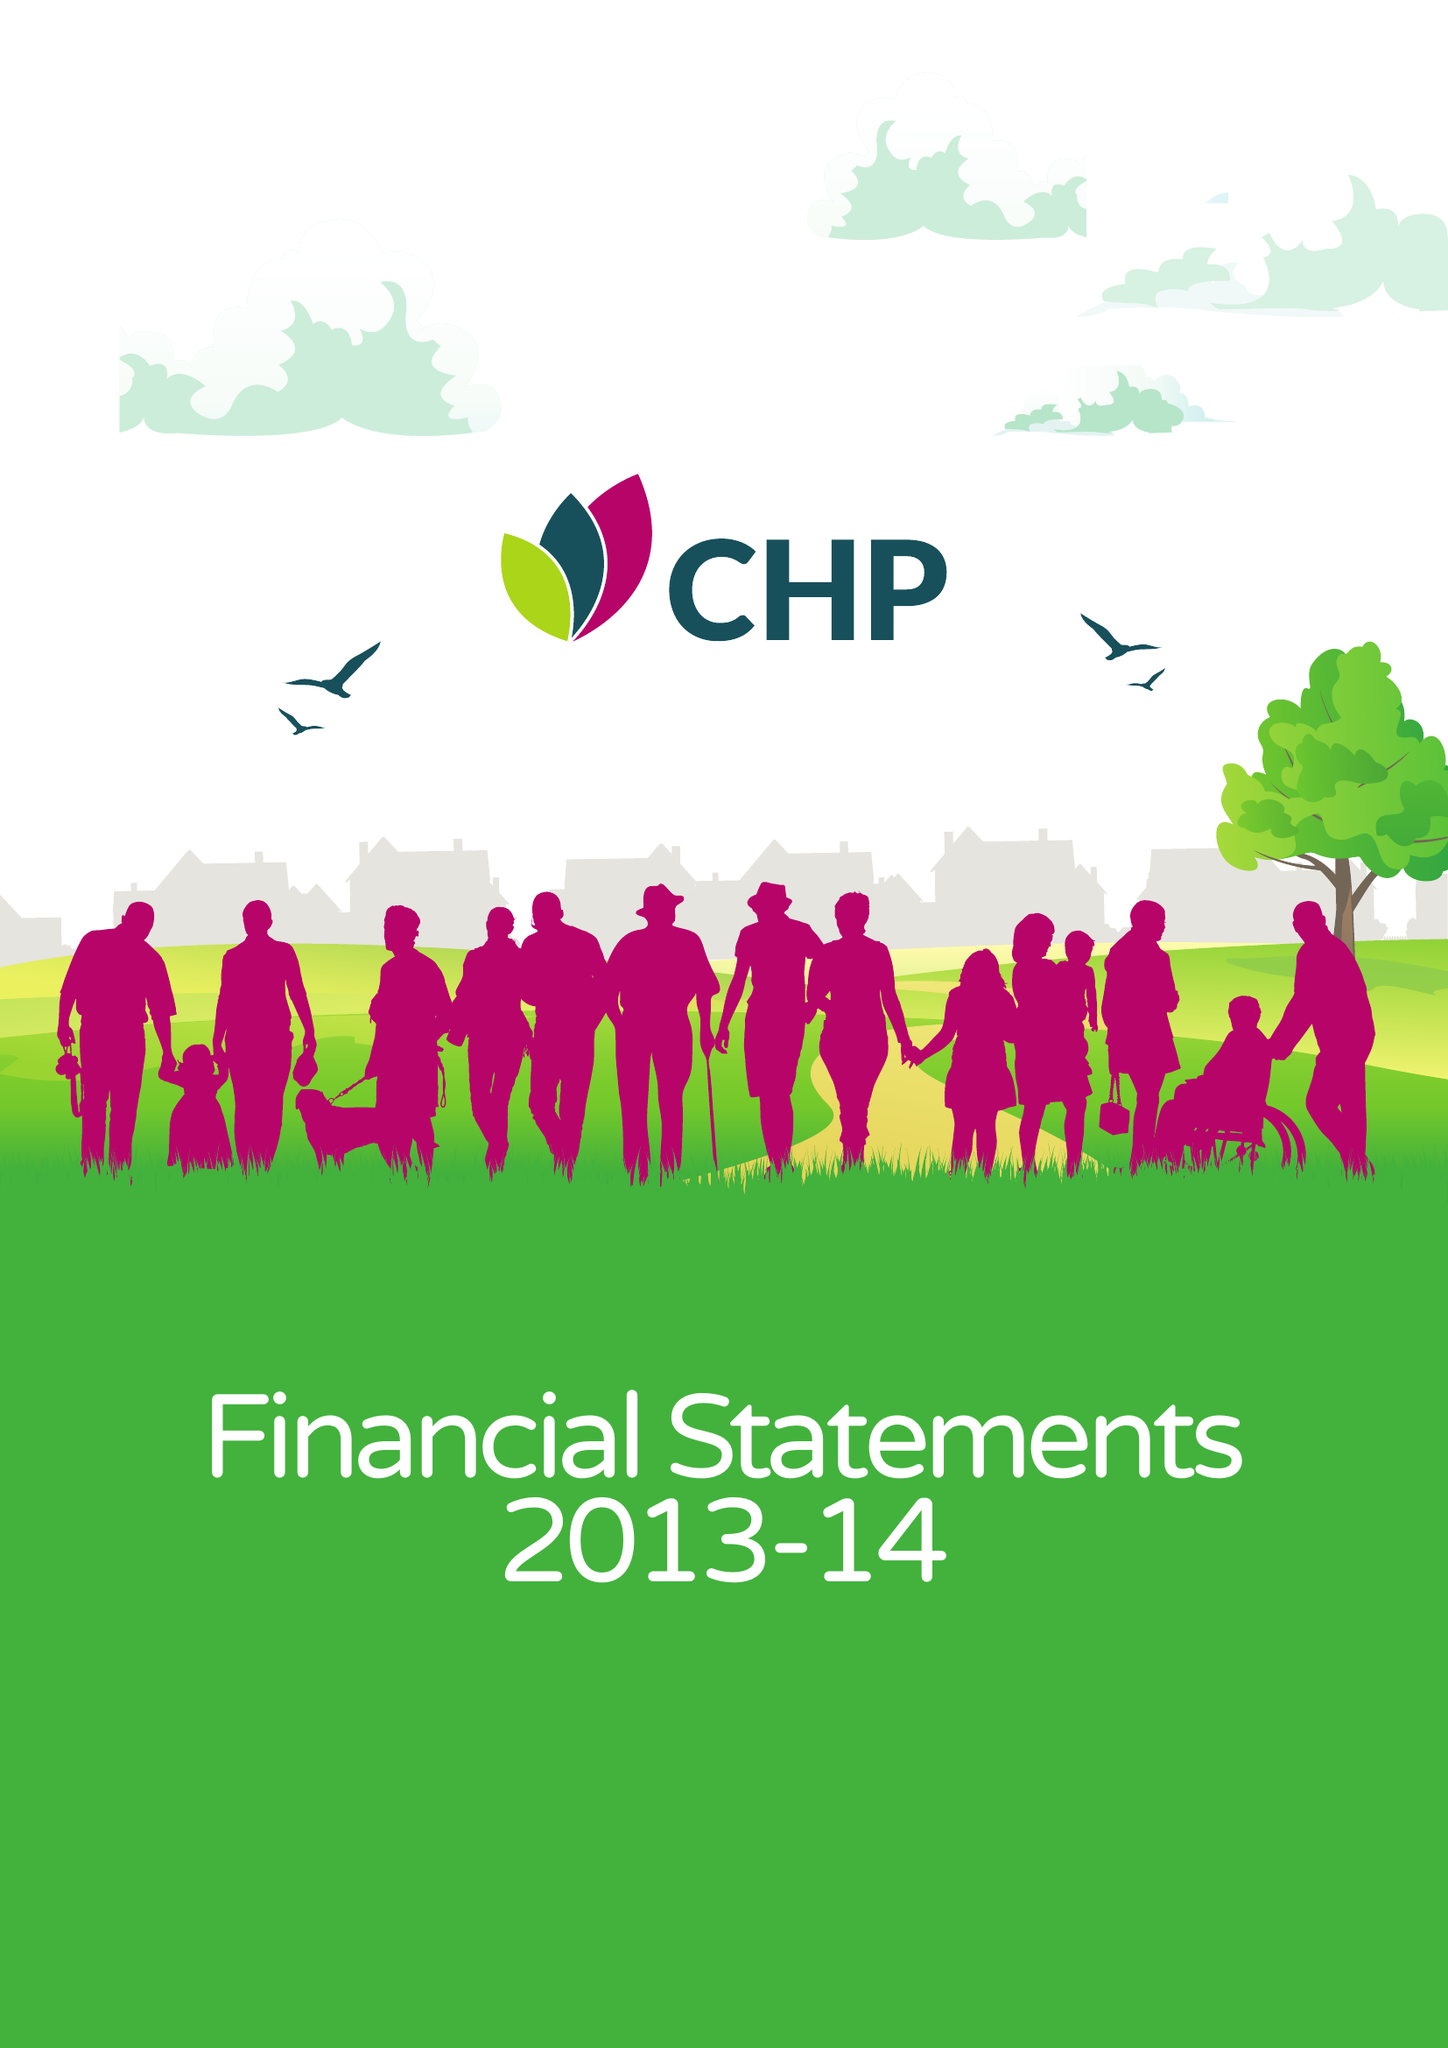What is the value for the charity_number?
Answer the question using a single word or phrase. 1149019 